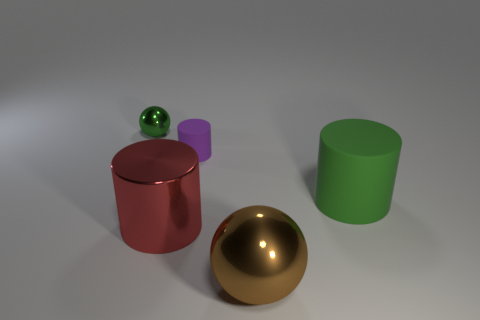There is a sphere that is the same color as the big matte cylinder; what material is it?
Keep it short and to the point. Metal. There is a cylinder that is the same color as the small metal object; what size is it?
Offer a very short reply. Large. How many other objects are the same shape as the purple thing?
Keep it short and to the point. 2. Is there anything else of the same color as the tiny matte cylinder?
Offer a terse response. No. How many metallic things are the same size as the purple matte object?
Your response must be concise. 1. Is the number of big brown metallic things left of the big brown shiny thing the same as the number of big metal objects that are right of the small matte object?
Provide a short and direct response. No. Is the material of the green cylinder the same as the large red cylinder?
Ensure brevity in your answer.  No. There is a green object that is to the right of the small metal ball; are there any green rubber cylinders behind it?
Offer a terse response. No. Is there a brown metal object of the same shape as the green shiny thing?
Make the answer very short. Yes. Does the large matte cylinder have the same color as the tiny ball?
Provide a succinct answer. Yes. 